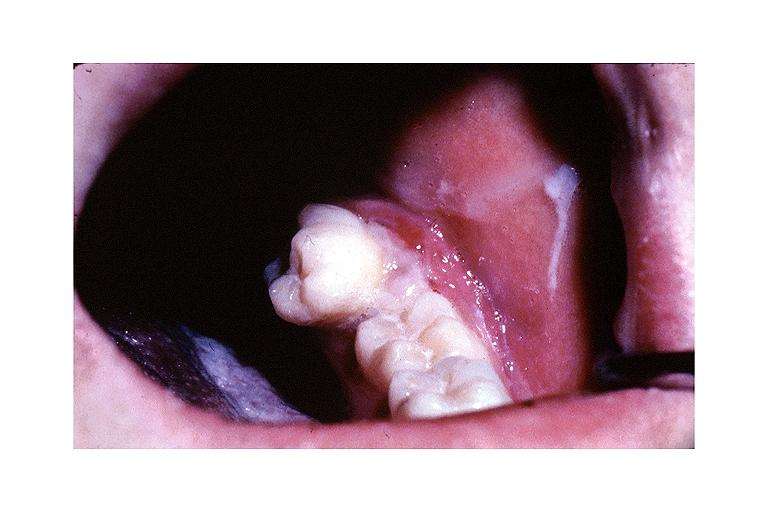s oral present?
Answer the question using a single word or phrase. Yes 